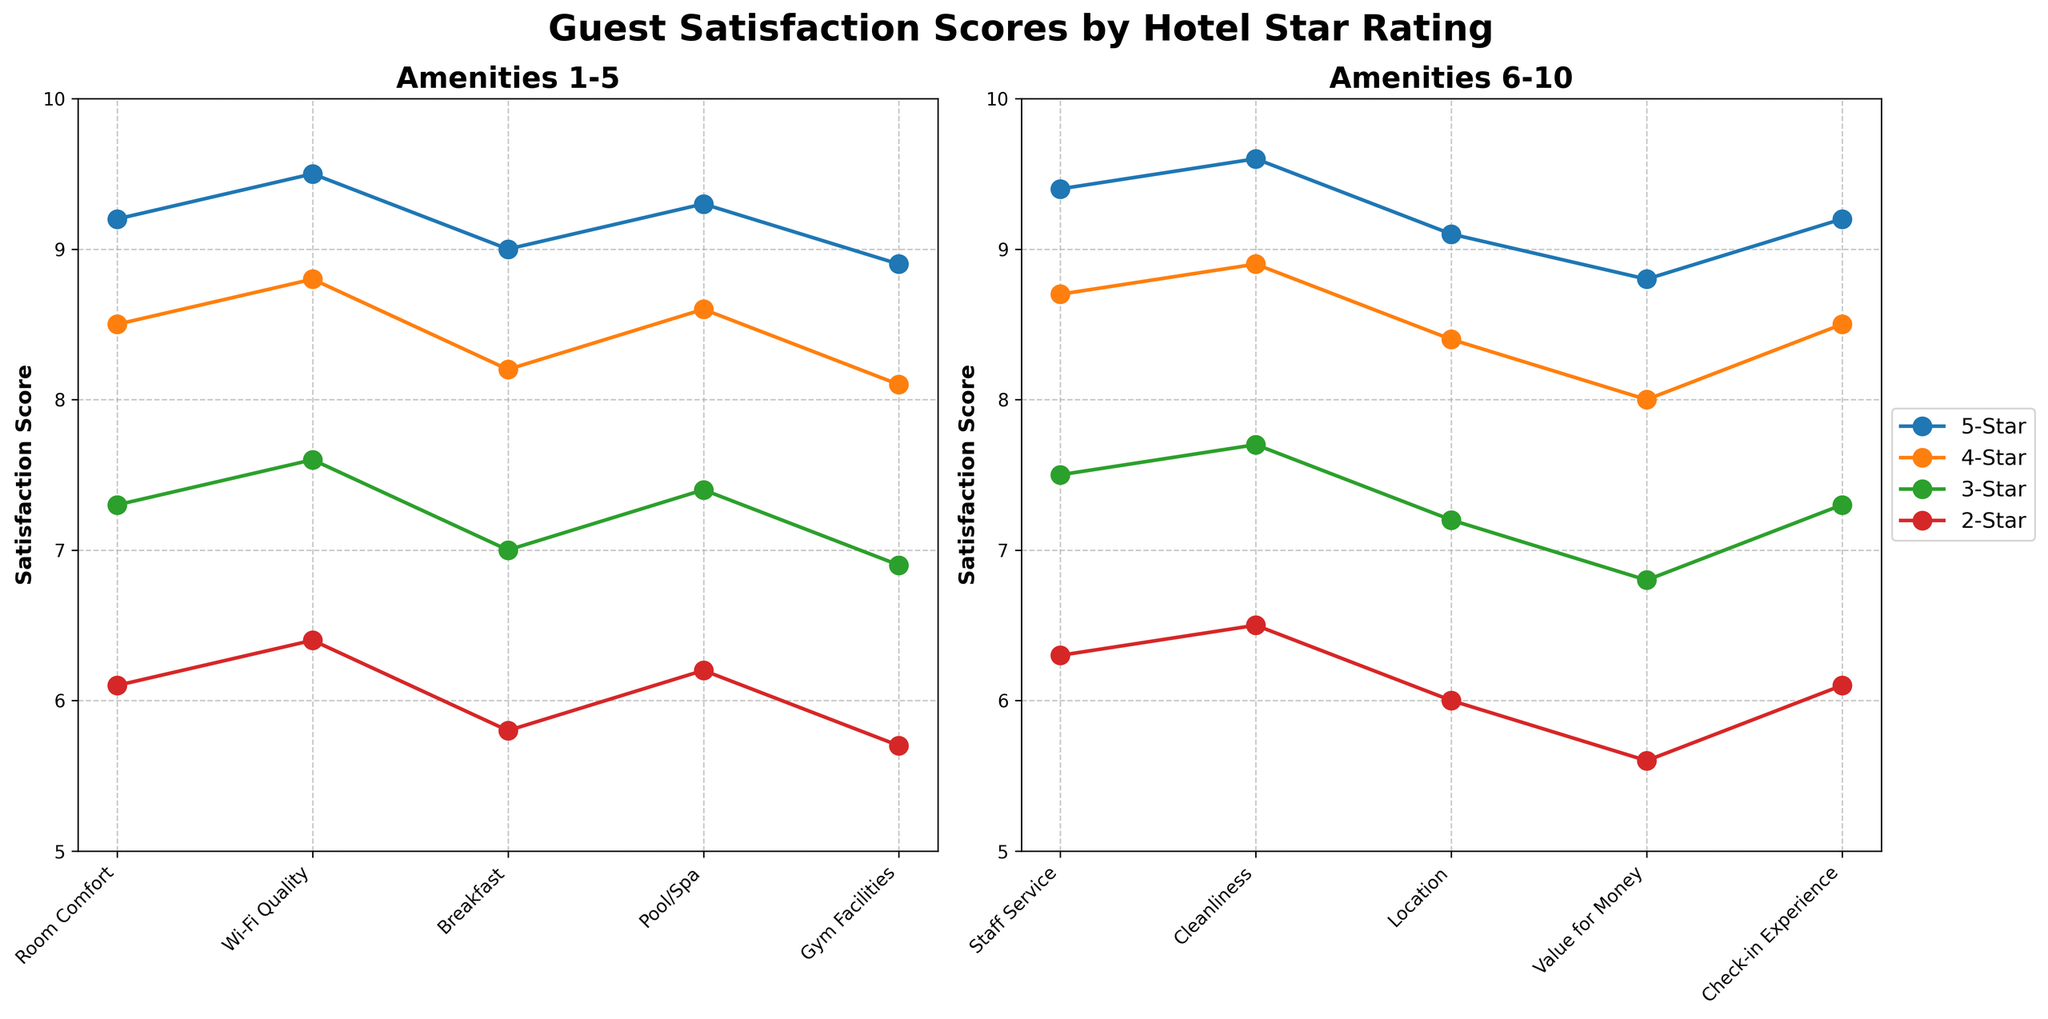Which amenity has the highest satisfaction score for 5-Star hotels? Look at the 5-Star series and compare the scores for each amenity. Cleanliness has the highest score of 9.6.
Answer: Cleanliness Which star rating shows the least variation in satisfaction scores across all amenities? Compare the range (difference between the highest and lowest value) for each star rating. 5-Star has the smallest range (9.6 - 8.8 = 0.8).
Answer: 5-Star How does the satisfaction score for Wi-Fi Quality in 4-Star hotels compare to Room Comfort in 3-Star hotels? Look at the score for Wi-Fi Quality in 4-Star hotels (8.8) and for Room Comfort in 3-Star hotels (7.3). Wi-Fi Quality in 4-Star hotels is higher by 1.5 points.
Answer: Wi-Fi Quality in 4-Star is higher by 1.5 What is the average satisfaction score for Gym Facilities across all star ratings? Add the Gym Facilities scores for each star rating and divide by the number of ratings: (8.9 + 8.1 + 6.9 + 5.7) / 4 = 7.4.
Answer: 7.4 Which amenity has the largest difference in satisfaction scores between 5-Star and 2-Star hotels? Calculate the difference for each amenity: Room Comfort (9.2-6.1), Wi-Fi Quality (9.5-6.4), etc. The largest difference is for Cleanliness (9.6-6.5 = 3.1).
Answer: Cleanliness Are the satisfaction scores for Breakfast in 3-Star and Pool/Spa in 2-Star hotels equal? Compare the scores for Breakfast in 3-Star (7.0) and Pool/Spa in 2-Star (6.2). They are not equal.
Answer: No In which star rating is the satisfaction score for Staff Service lower than that for Wi-Fi Quality? Compare the scores for Staff Service and Wi-Fi Quality across all star ratings: 5-Star (9.4 < 9.5), 4-Star (8.7 < 8.8), etc. This is true for all star ratings.
Answer: All ratings What is the total satisfaction score for Check-in Experience and Location in 5-Star hotels? Add the scores for Check-in Experience (9.2) and Location (9.1) for 5-Star hotels: 9.2 + 9.1 = 18.3.
Answer: 18.3 How many amenities have a 2-Star satisfaction score equal to or greater than 6.0? Count the amenities with scores >= 6.0 in 2-Star hotels: Room Comfort, Wi-Fi Quality, Pool/Spa, Staff Service, Cleanliness. There are 5.
Answer: 5 Which amenities' satisfaction scores are consistently ranked in the same order across all star ratings? For each star rating, compare the relative ranking of amenities. Cleanliness and Wi-Fi Quality consistently rank highest across all star ratings.
Answer: Cleanliness, Wi-Fi Quality 